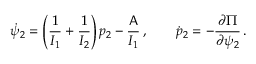<formula> <loc_0><loc_0><loc_500><loc_500>\dot { \psi } _ { 2 } = \left ( \frac { 1 } { I _ { 1 } } + \frac { 1 } { I _ { 2 } } \right ) p _ { 2 } - \frac { A } { I _ { 1 } } \, , \quad \dot { p } _ { 2 } = - \frac { \partial \Pi } { \partial \psi _ { 2 } } \, .</formula> 